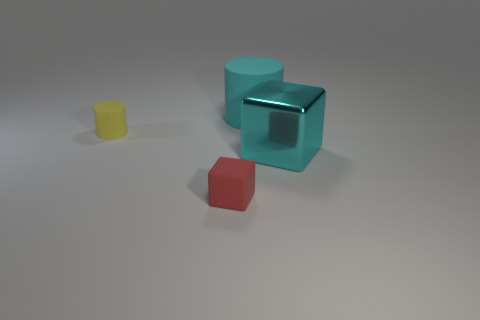Add 4 yellow cylinders. How many objects exist? 8 Subtract all cyan blocks. How many blocks are left? 1 Subtract all gray rubber cylinders. Subtract all small red blocks. How many objects are left? 3 Add 1 cyan shiny cubes. How many cyan shiny cubes are left? 2 Add 2 tiny red objects. How many tiny red objects exist? 3 Subtract 0 brown cylinders. How many objects are left? 4 Subtract all blue cylinders. Subtract all yellow balls. How many cylinders are left? 2 